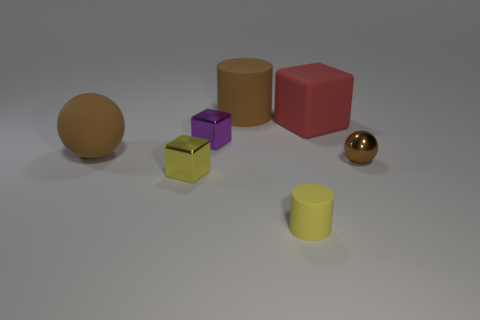What size is the cylinder that is left of the cylinder that is in front of the brown metal object?
Your response must be concise. Large. What color is the other tiny metallic object that is the same shape as the purple object?
Make the answer very short. Yellow. How many other things are the same color as the small rubber object?
Ensure brevity in your answer.  1. The matte block has what size?
Keep it short and to the point. Large. Is the yellow rubber object the same size as the purple cube?
Keep it short and to the point. Yes. There is a tiny metal object that is both behind the tiny yellow metallic thing and to the left of the big red matte thing; what is its color?
Your response must be concise. Purple. How many yellow blocks are the same material as the large red block?
Your answer should be very brief. 0. How many shiny cubes are there?
Ensure brevity in your answer.  2. Do the purple thing and the sphere that is right of the big red object have the same size?
Your answer should be very brief. Yes. What material is the yellow object that is left of the matte cylinder behind the brown shiny ball?
Keep it short and to the point. Metal. 